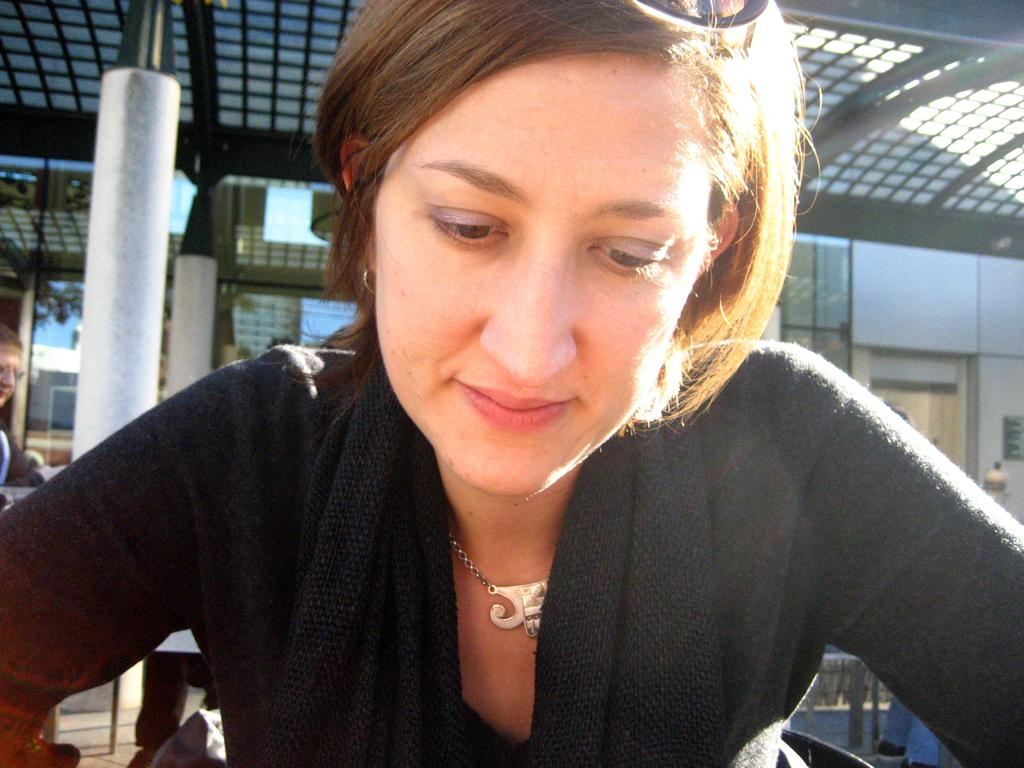Who is the main subject in the image? There is a woman in the image. Can you describe the position of the person behind the woman? There is a person standing behind the woman. What type of structure is visible in the image? There is a roof in the image. What type of nut can be seen falling from the roof in the image? There is no nut falling from the roof in the image; it only shows a woman and a person standing behind her. 